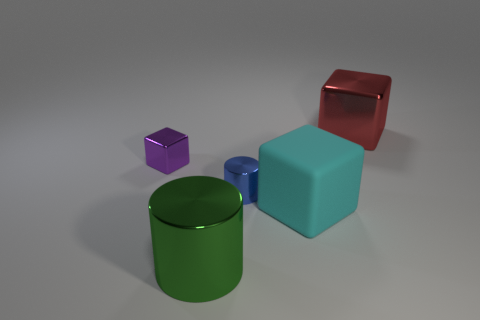Add 1 tiny blue metallic things. How many objects exist? 6 Subtract all blocks. How many objects are left? 2 Add 3 big brown metal balls. How many big brown metal balls exist? 3 Subtract 1 cyan cubes. How many objects are left? 4 Subtract all metal spheres. Subtract all green metal things. How many objects are left? 4 Add 2 blue objects. How many blue objects are left? 3 